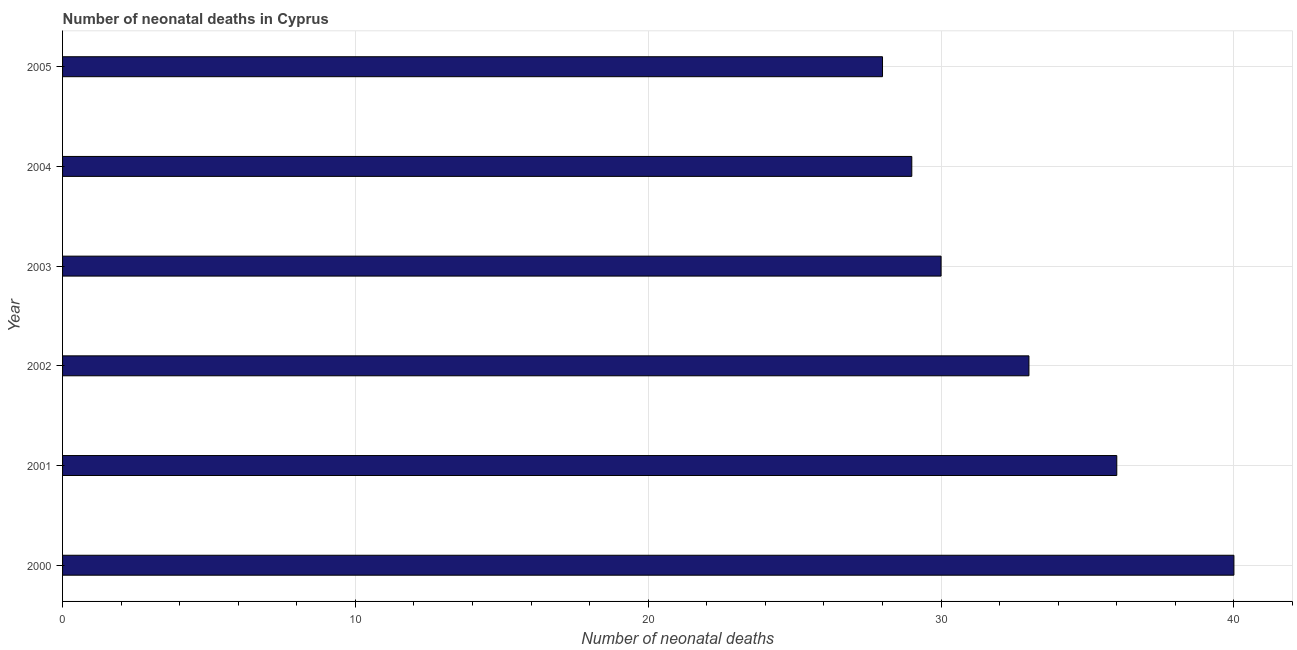Does the graph contain any zero values?
Make the answer very short. No. What is the title of the graph?
Offer a very short reply. Number of neonatal deaths in Cyprus. What is the label or title of the X-axis?
Provide a succinct answer. Number of neonatal deaths. What is the label or title of the Y-axis?
Provide a succinct answer. Year. Across all years, what is the minimum number of neonatal deaths?
Ensure brevity in your answer.  28. What is the sum of the number of neonatal deaths?
Ensure brevity in your answer.  196. What is the difference between the number of neonatal deaths in 2004 and 2005?
Make the answer very short. 1. What is the average number of neonatal deaths per year?
Provide a short and direct response. 32. What is the median number of neonatal deaths?
Provide a succinct answer. 31.5. In how many years, is the number of neonatal deaths greater than 36 ?
Your response must be concise. 1. Is the number of neonatal deaths in 2000 less than that in 2001?
Your response must be concise. No. What is the Number of neonatal deaths in 2001?
Your answer should be very brief. 36. What is the Number of neonatal deaths in 2002?
Ensure brevity in your answer.  33. What is the Number of neonatal deaths in 2003?
Give a very brief answer. 30. What is the Number of neonatal deaths of 2004?
Provide a succinct answer. 29. What is the Number of neonatal deaths of 2005?
Offer a very short reply. 28. What is the difference between the Number of neonatal deaths in 2000 and 2001?
Ensure brevity in your answer.  4. What is the difference between the Number of neonatal deaths in 2000 and 2004?
Offer a terse response. 11. What is the difference between the Number of neonatal deaths in 2001 and 2002?
Provide a short and direct response. 3. What is the difference between the Number of neonatal deaths in 2004 and 2005?
Your response must be concise. 1. What is the ratio of the Number of neonatal deaths in 2000 to that in 2001?
Make the answer very short. 1.11. What is the ratio of the Number of neonatal deaths in 2000 to that in 2002?
Keep it short and to the point. 1.21. What is the ratio of the Number of neonatal deaths in 2000 to that in 2003?
Provide a succinct answer. 1.33. What is the ratio of the Number of neonatal deaths in 2000 to that in 2004?
Offer a terse response. 1.38. What is the ratio of the Number of neonatal deaths in 2000 to that in 2005?
Your answer should be very brief. 1.43. What is the ratio of the Number of neonatal deaths in 2001 to that in 2002?
Offer a terse response. 1.09. What is the ratio of the Number of neonatal deaths in 2001 to that in 2004?
Your response must be concise. 1.24. What is the ratio of the Number of neonatal deaths in 2001 to that in 2005?
Give a very brief answer. 1.29. What is the ratio of the Number of neonatal deaths in 2002 to that in 2003?
Make the answer very short. 1.1. What is the ratio of the Number of neonatal deaths in 2002 to that in 2004?
Your answer should be compact. 1.14. What is the ratio of the Number of neonatal deaths in 2002 to that in 2005?
Give a very brief answer. 1.18. What is the ratio of the Number of neonatal deaths in 2003 to that in 2004?
Your response must be concise. 1.03. What is the ratio of the Number of neonatal deaths in 2003 to that in 2005?
Offer a terse response. 1.07. What is the ratio of the Number of neonatal deaths in 2004 to that in 2005?
Make the answer very short. 1.04. 